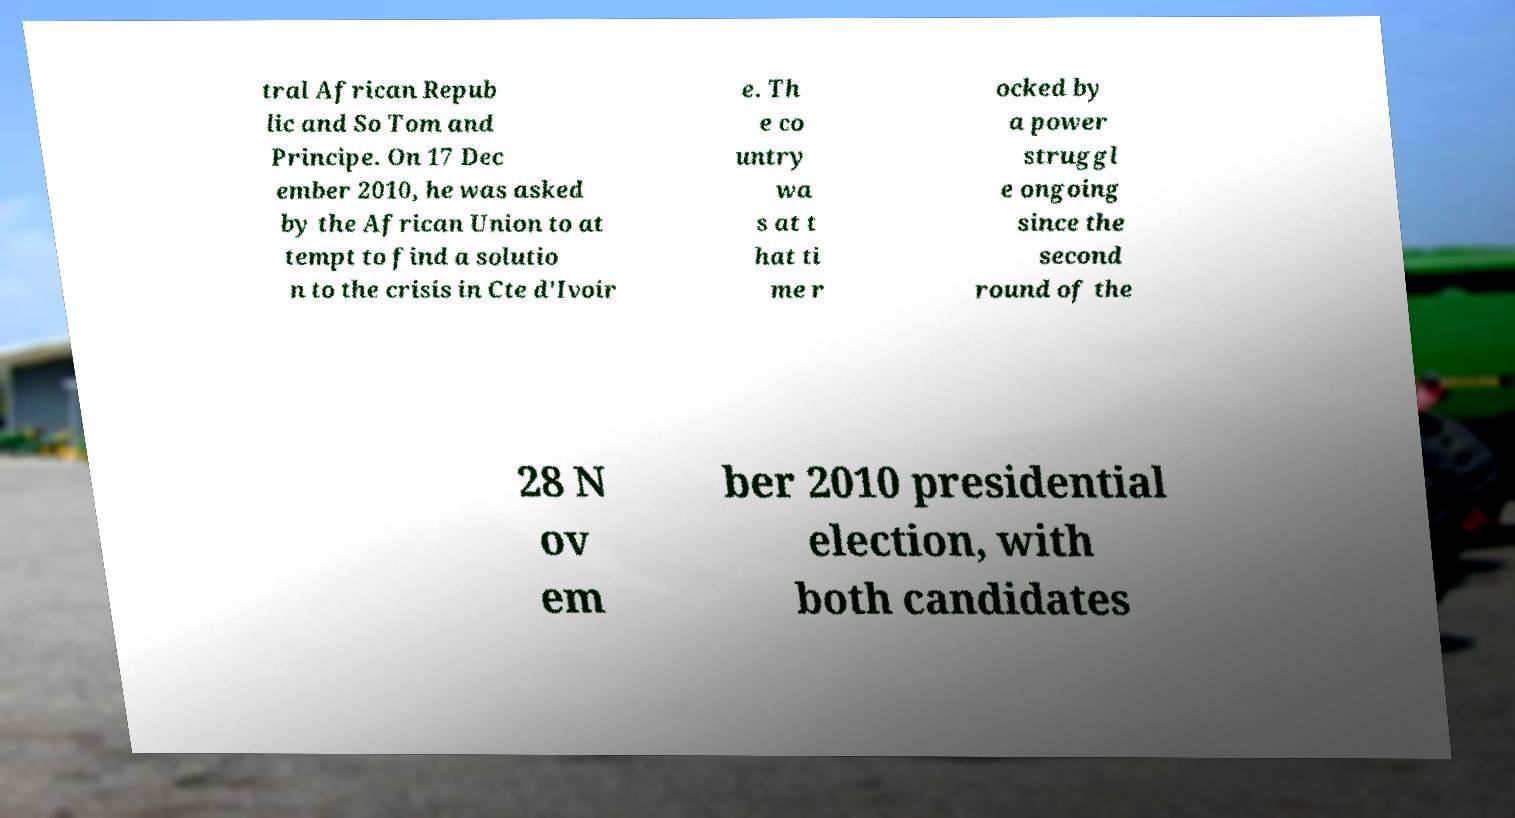Please read and relay the text visible in this image. What does it say? tral African Repub lic and So Tom and Principe. On 17 Dec ember 2010, he was asked by the African Union to at tempt to find a solutio n to the crisis in Cte d'Ivoir e. Th e co untry wa s at t hat ti me r ocked by a power struggl e ongoing since the second round of the 28 N ov em ber 2010 presidential election, with both candidates 